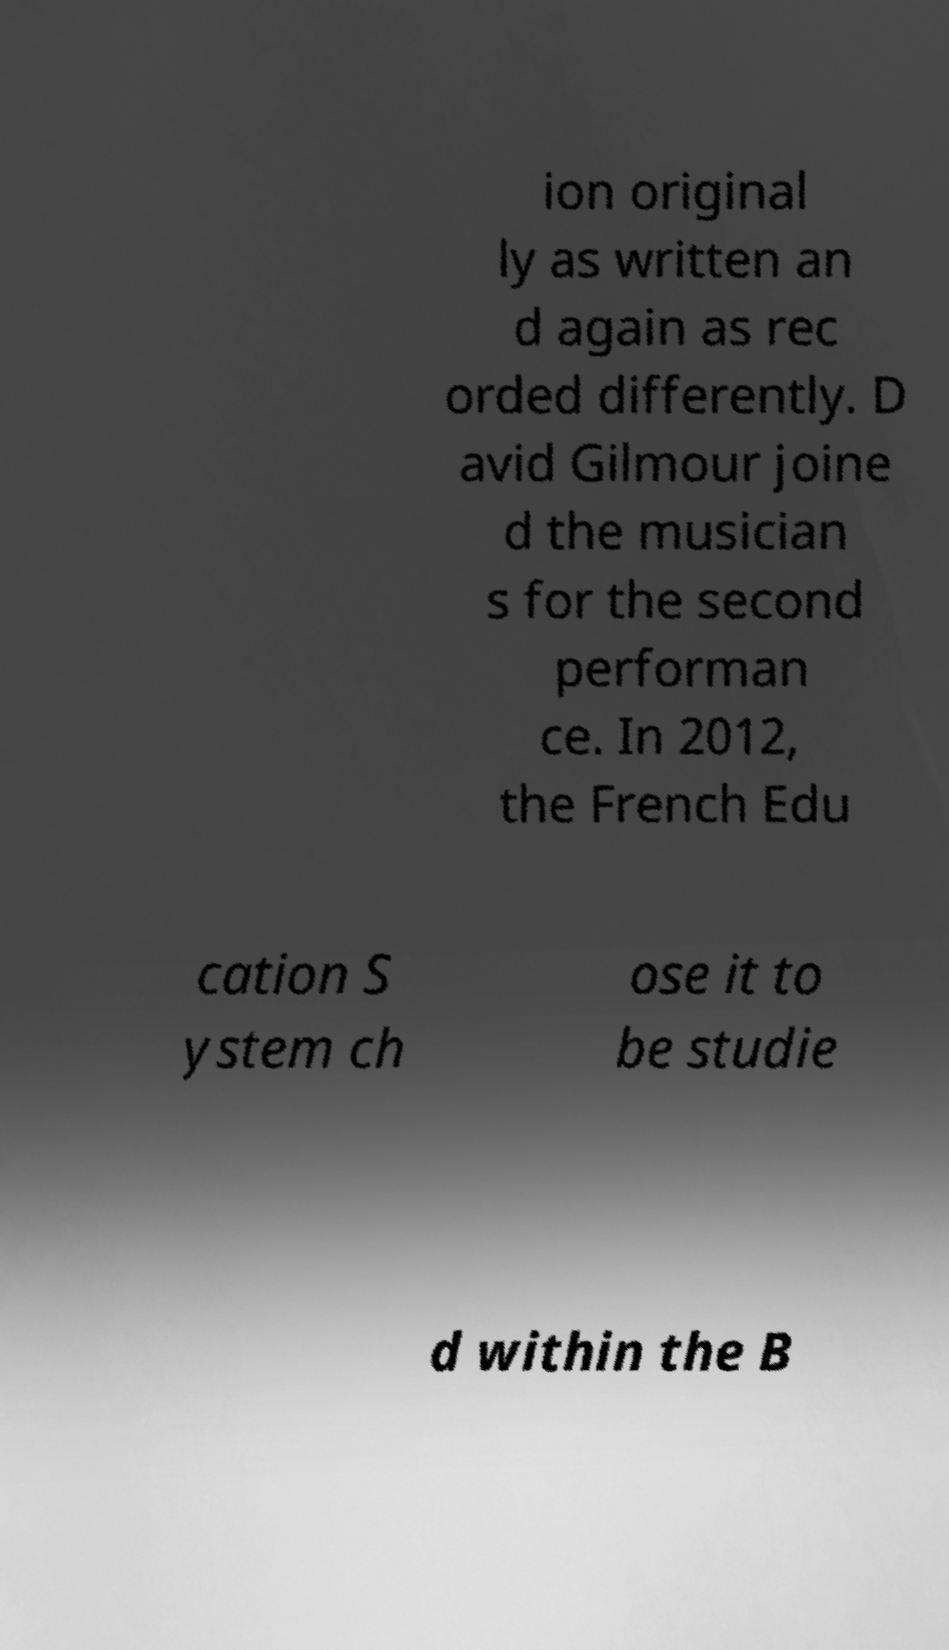Can you read and provide the text displayed in the image?This photo seems to have some interesting text. Can you extract and type it out for me? ion original ly as written an d again as rec orded differently. D avid Gilmour joine d the musician s for the second performan ce. In 2012, the French Edu cation S ystem ch ose it to be studie d within the B 